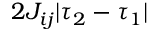<formula> <loc_0><loc_0><loc_500><loc_500>2 J _ { i j } | \tau _ { 2 } - \tau _ { 1 } |</formula> 